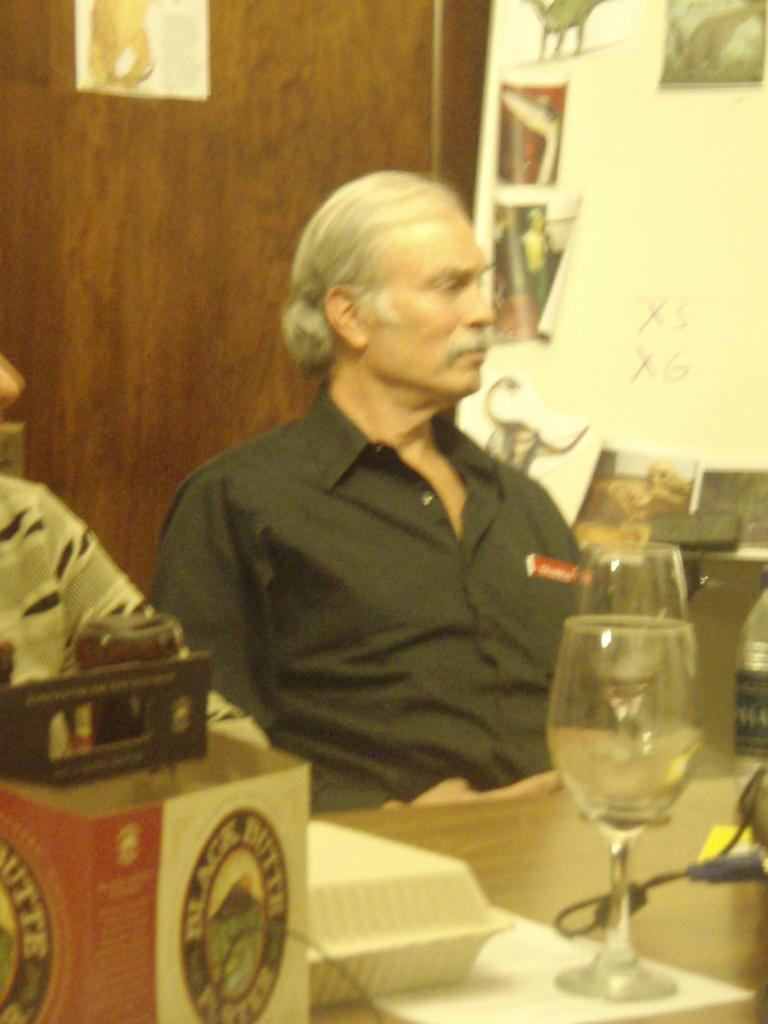What is on the table in the image? There is a cardboard box and glasses on the table. Are there any other items on the table? Yes, there are other items on the table. Where is the table located in the image? The table is in the foreground area of the image. What can be seen in the background of the image? There are men, posters, and a wall in the background. What type of butter is being used as an example by the achiever in the image? There is no butter or achiever present in the image. 